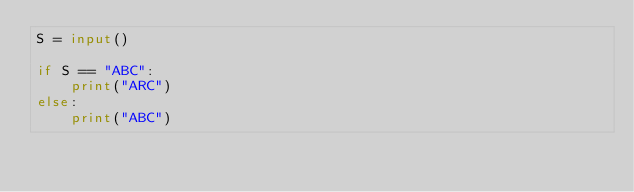Convert code to text. <code><loc_0><loc_0><loc_500><loc_500><_Python_>S = input()

if S == "ABC":
    print("ARC")
else:
    print("ABC")
</code> 